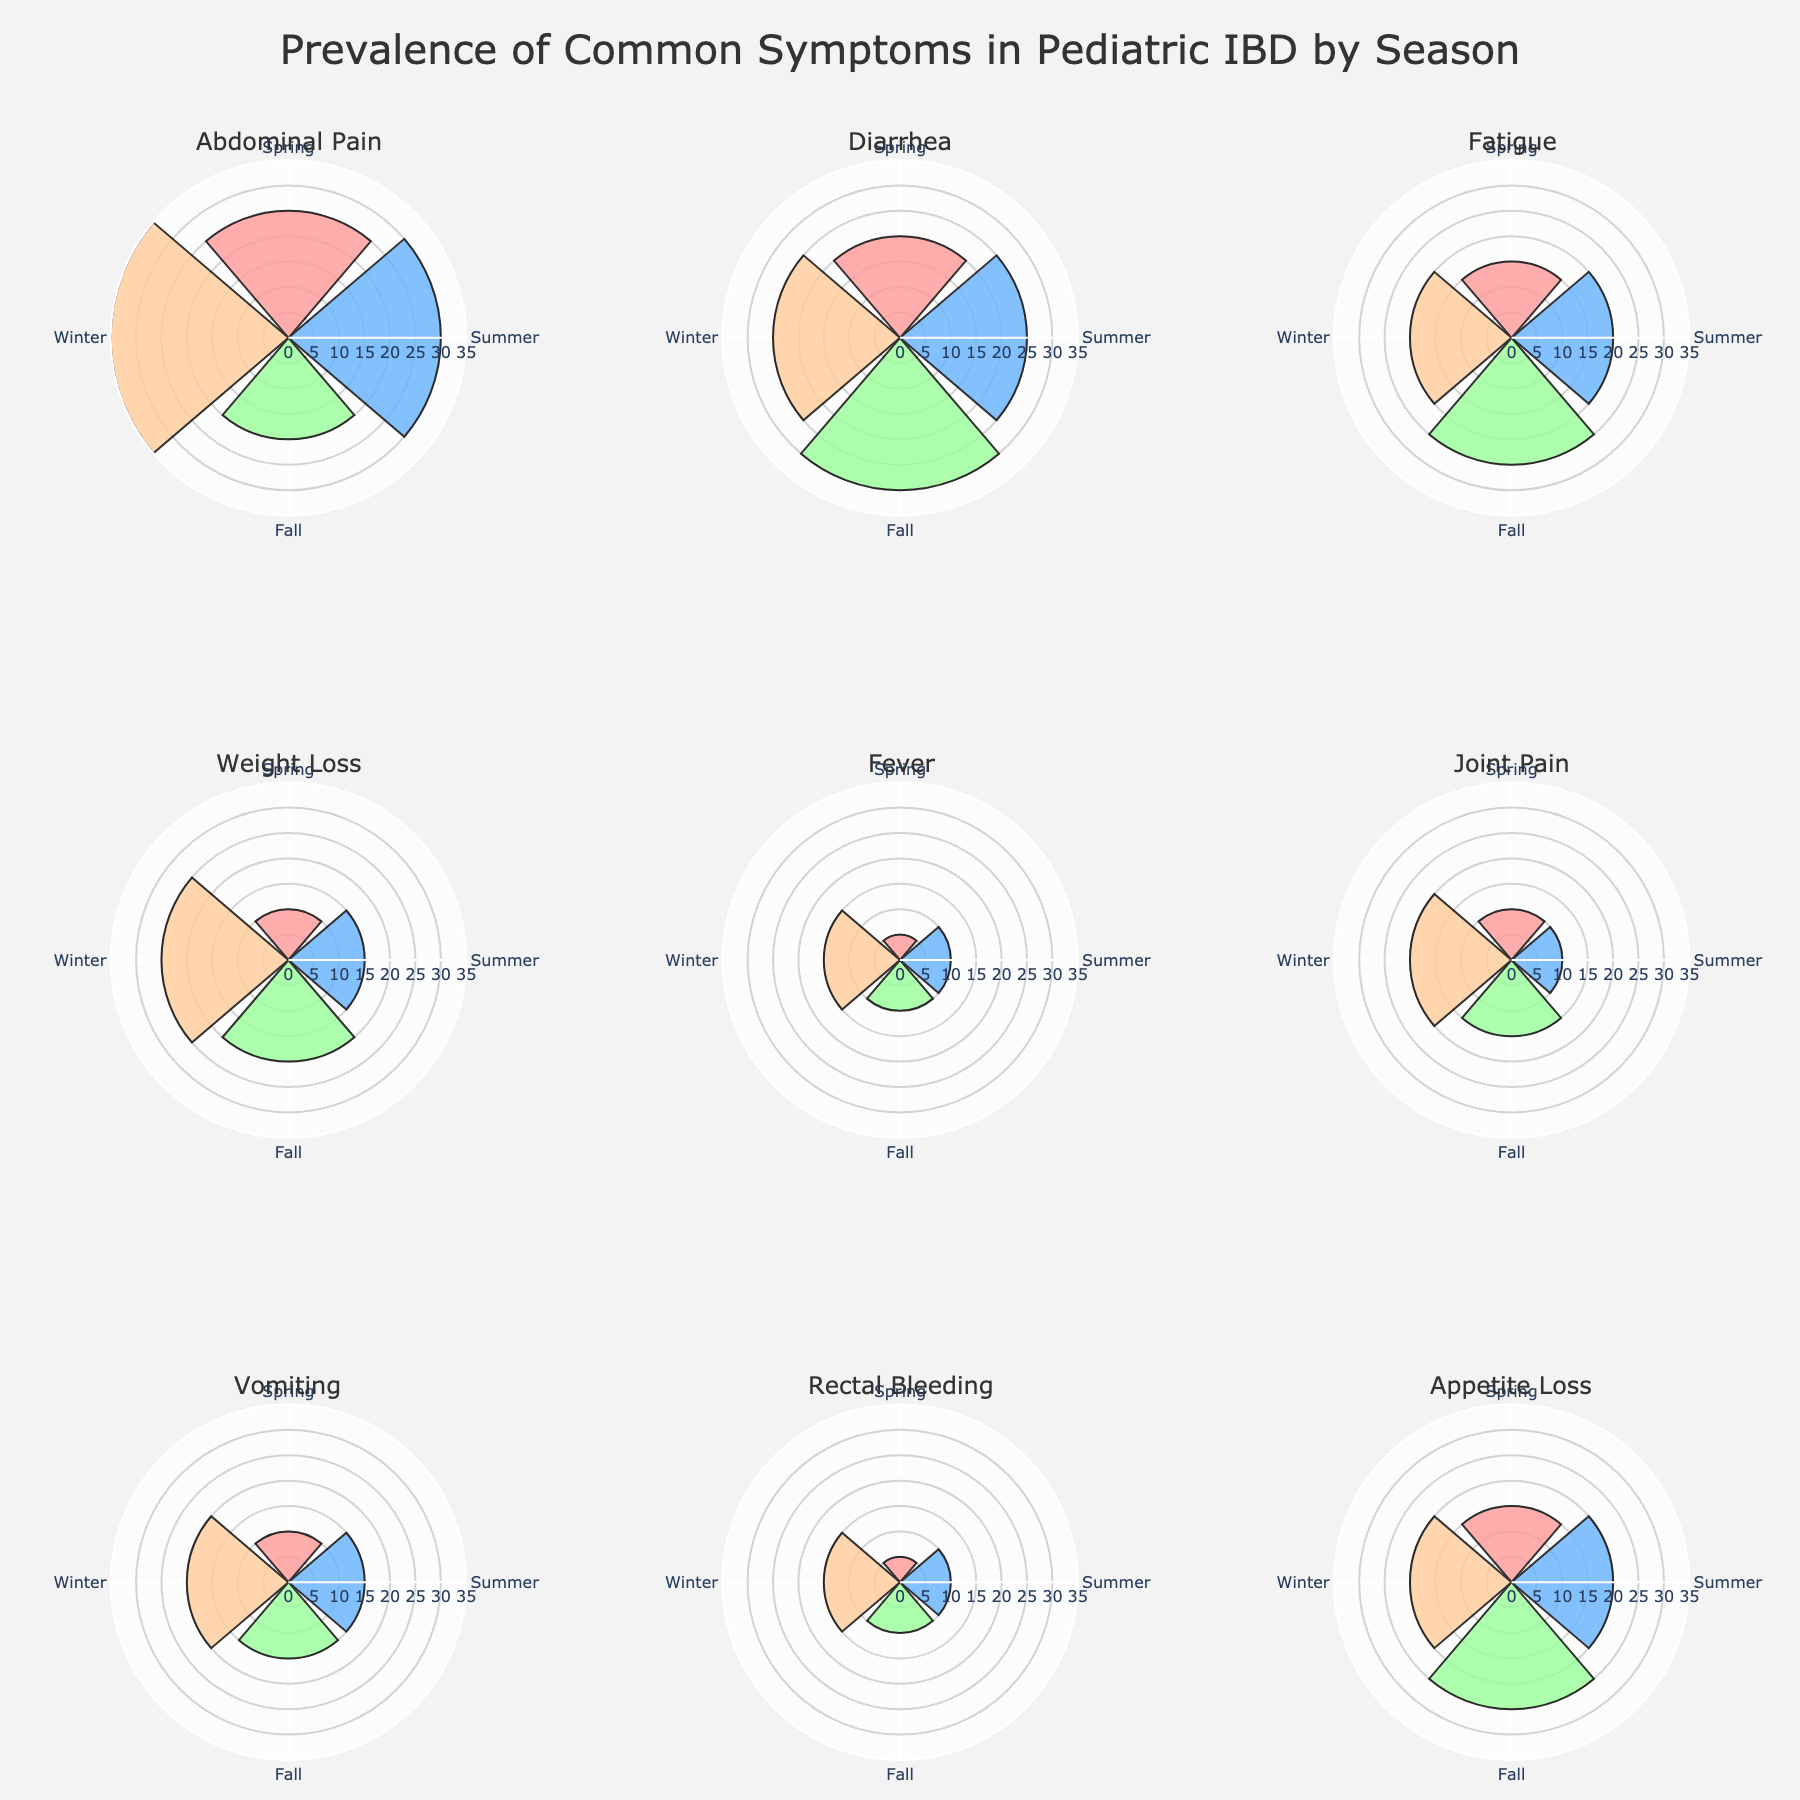What symptom has the highest prevalence in the Winter? Look at the subplot corresponding to Winter for each symptom and identify the symptom with the highest bar height.
Answer: Abdominal Pain Which season shows the lowest prevalence for Fever? Check the fever subplot and compare the bar heights for the four seasons. The shortest bar indicates the lowest prevalence.
Answer: Spring How does the prevalence of Diarrhea in Summer compare to Fall? Observe the diarrhea subplot and compare the bar heights for Summer and Fall. The taller bar indicates a higher prevalence.
Answer: Fall has a higher prevalence than Summer Which symptom has a consistent prevalence of 20 across three seasons? Look for a subplot where three bars are of the same height at the value of 20.
Answer: Fatigue What’s the average prevalence of Appetite Loss in Spring and Fall? Add the prevalence values for Spring and Fall and then divide by 2. (15 + 25) / 2 = 20
Answer: 20 Is the prevalence of Joint Pain higher in Winter or Summer? Compare the bar heights for Joint Pain in Winter and Summer.
Answer: Winter How does the prevalence of Rectal Bleeding change from Spring to Winter? Check the subplot for Rectal Bleeding and note the heights of the bars from Spring to Winter. It increases from 5 to 15.
Answer: Increases What is the difference in prevalence of Vomiting between Winter and Spring? Subtract the Spring value from the Winter value for vomiting. 20 - 10 = 10
Answer: 10 Which symptoms peak in the Fall? Identify subplots where the tallest bar is for the Fall season.
Answer: Diarrhea and Fatigue What is the median prevalence value for all symptoms in Winter? List all the Winter values, then find the median: 35, 25, 20, 25, 15, 20, 20, 15, 20. The median is the middle value when they are ordered.
Answer: 20 